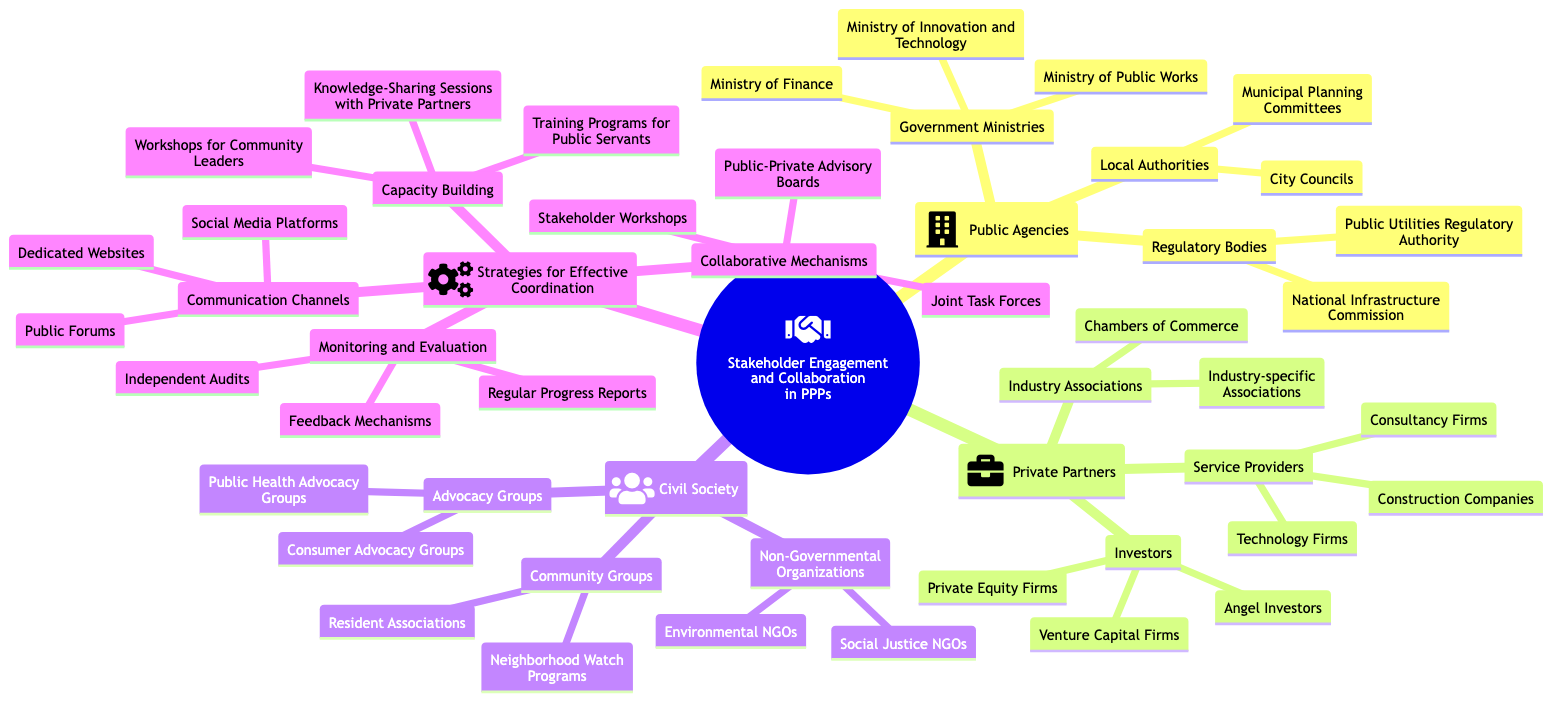What are the categories of Public Agencies in the diagram? The diagram shows three categories under Public Agencies: Government Ministries, Regulatory Bodies, and Local Authorities. Each category includes specific entities.
Answer: Government Ministries, Regulatory Bodies, Local Authorities How many types of Private Partners are listed? The diagram lists three types of Private Partners: Investors, Service Providers, and Industry Associations. This count is derived from the main branches under the Private Partners category.
Answer: 3 What is one example of a Non-Governmental Organization? Under the Civil Society category, one type listed is Non-Governmental Organizations, which includes Environmental NGOs as an example. Therefore, the answer is found within the elements listed under that category.
Answer: Environmental NGOs Which communication channel is mentioned for effective coordination? The diagram lists Public Forums as one of the communication channels under Strategies for Effective Coordination. This can be identified as a direct component within the communication channels section.
Answer: Public Forums What is the purpose of Joint Task Forces in this context? Joint Task Forces are categorized under Collaborative Mechanisms, which means their purpose is to foster collaboration among stakeholders to enhance coordination and facilitate specific projects. While this is not directly stated in the diagram, it is inferred from the category they are part of.
Answer: Collaboration How many organizations are listed under Investors? There are three specific organizations listed under Investors: Venture Capital Firms, Private Equity Firms, and Angel Investors. Simply counting the items listed provides the answer.
Answer: 3 Which group is listed under Advocacy Groups? Under Civil Society, Advocacy Groups are specifically mentioned, with Consumer Advocacy Groups being one of the examples listed. Hence, this is straightforward from the related section in the diagram.
Answer: Consumer Advocacy Groups What mechanism is related to Monitoring and Evaluation? The Regular Progress Reports are mentioned as one part of Monitoring and Evaluation strategies, indicating their role in overseeing project timelines and milestones. This can be found directly under the specific section on Monitoring and Evaluation.
Answer: Regular Progress Reports 